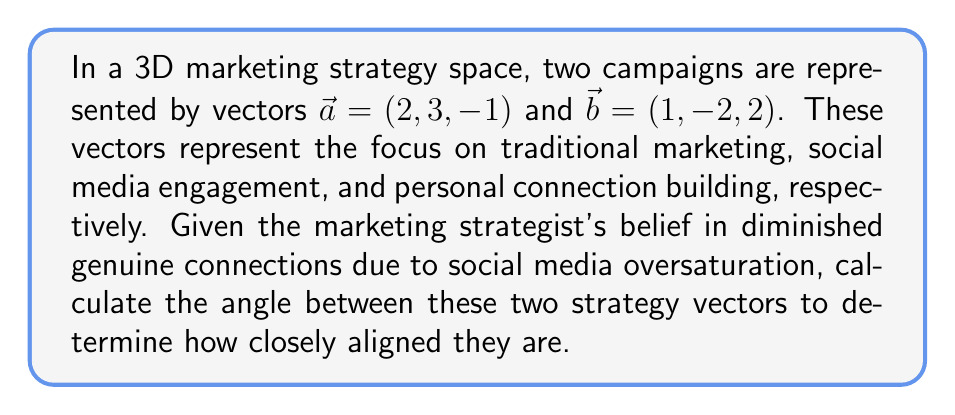Can you solve this math problem? To find the angle between two vectors in 3D space, we use the dot product formula:

$$\cos \theta = \frac{\vec{a} \cdot \vec{b}}{|\vec{a}| |\vec{b}|}$$

Where $\theta$ is the angle between the vectors, $\vec{a} \cdot \vec{b}$ is the dot product, and $|\vec{a}|$ and $|\vec{b}|$ are the magnitudes of the vectors.

Step 1: Calculate the dot product $\vec{a} \cdot \vec{b}$
$$\vec{a} \cdot \vec{b} = (2)(1) + (3)(-2) + (-1)(2) = 2 - 6 - 2 = -6$$

Step 2: Calculate the magnitudes of the vectors
$$|\vec{a}| = \sqrt{2^2 + 3^2 + (-1)^2} = \sqrt{4 + 9 + 1} = \sqrt{14}$$
$$|\vec{b}| = \sqrt{1^2 + (-2)^2 + 2^2} = \sqrt{1 + 4 + 4} = 3$$

Step 3: Substitute into the formula
$$\cos \theta = \frac{-6}{\sqrt{14} \cdot 3} = \frac{-6}{3\sqrt{14}}$$

Step 4: Take the inverse cosine (arccos) of both sides
$$\theta = \arccos\left(\frac{-6}{3\sqrt{14}}\right)$$

Step 5: Calculate the result
$$\theta \approx 2.5936 \text{ radians}$$

Convert to degrees:
$$\theta \approx 148.60°$$

This large angle (greater than 90°) indicates that the two marketing strategies are quite different, aligning with the persona's belief that social media has oversaturated the market and diminished genuine connections.
Answer: $\theta \approx 148.60°$ or $2.5936$ radians 